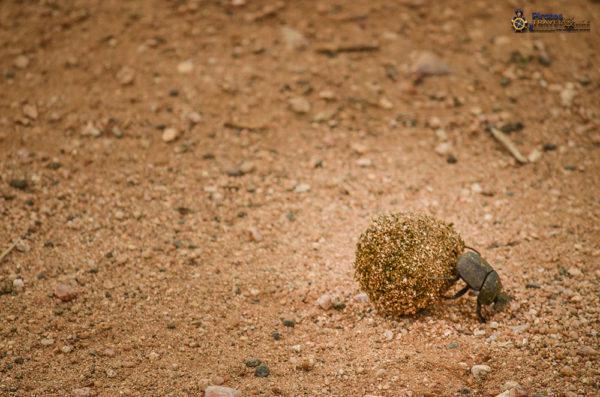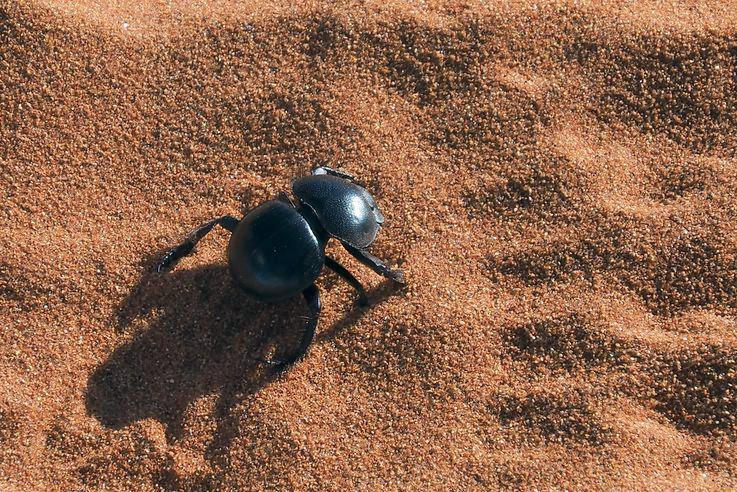The first image is the image on the left, the second image is the image on the right. Examine the images to the left and right. Is the description "One of the dung beetles is not near a ball of dung." accurate? Answer yes or no. Yes. The first image is the image on the left, the second image is the image on the right. Given the left and right images, does the statement "Each image includes at least one beetle in contact with a brown ball." hold true? Answer yes or no. No. 